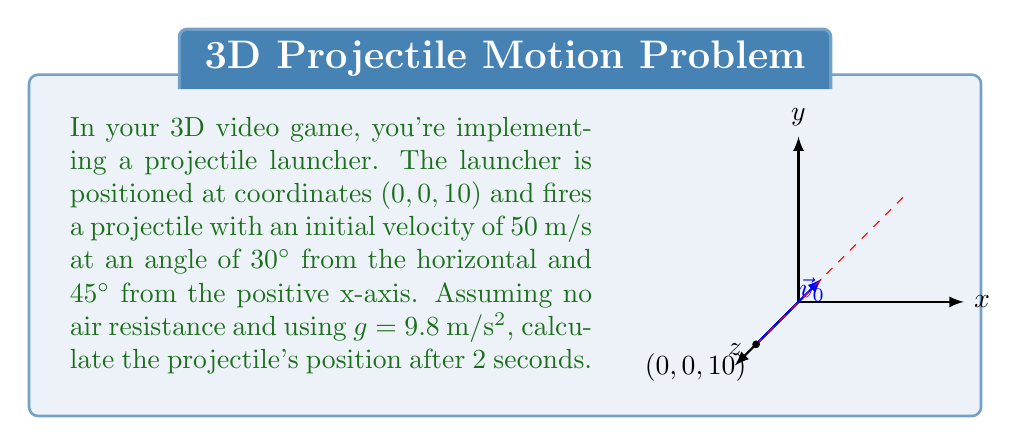Could you help me with this problem? To solve this problem, we'll use the equations of motion for a projectile in 3D space. Let's break it down step-by-step:

1) First, we need to decompose the initial velocity into its x, y, and z components:

   $v_{0x} = v_0 \cos(30°) \cos(45°) = 50 \cdot \frac{\sqrt{3}}{2} \cdot \frac{\sqrt{2}}{2} = 25\sqrt{3}$ m/s
   $v_{0y} = v_0 \cos(30°) \sin(45°) = 50 \cdot \frac{\sqrt{3}}{2} \cdot \frac{\sqrt{2}}{2} = 25\sqrt{3}$ m/s
   $v_{0z} = v_0 \sin(30°) = 50 \cdot \frac{1}{2} = 25$ m/s

2) Now, we can use the equations of motion:

   $x = x_0 + v_{0x}t$
   $y = y_0 + v_{0y}t$
   $z = z_0 + v_{0z}t - \frac{1}{2}gt^2$

3) Substituting our values (x₀ = 0, y₀ = 0, z₀ = 10, t = 2):

   $x = 0 + 25\sqrt{3} \cdot 2 = 50\sqrt{3}$ m
   $y = 0 + 25\sqrt{3} \cdot 2 = 50\sqrt{3}$ m
   $z = 10 + 25 \cdot 2 - \frac{1}{2} \cdot 9.8 \cdot 2^2 = 60 - 19.6 = 40.4$ m

4) Therefore, the position after 2 seconds is $(50\sqrt{3}, 50\sqrt{3}, 40.4)$ meters.
Answer: $(50\sqrt{3}, 50\sqrt{3}, 40.4)$ m 